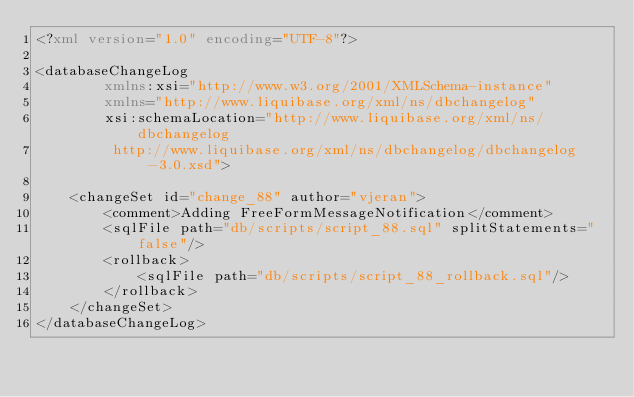Convert code to text. <code><loc_0><loc_0><loc_500><loc_500><_XML_><?xml version="1.0" encoding="UTF-8"?>

<databaseChangeLog
        xmlns:xsi="http://www.w3.org/2001/XMLSchema-instance"
        xmlns="http://www.liquibase.org/xml/ns/dbchangelog"
        xsi:schemaLocation="http://www.liquibase.org/xml/ns/dbchangelog
         http://www.liquibase.org/xml/ns/dbchangelog/dbchangelog-3.0.xsd">

    <changeSet id="change_88" author="vjeran">
        <comment>Adding FreeFormMessageNotification</comment>
        <sqlFile path="db/scripts/script_88.sql" splitStatements="false"/>
        <rollback>
            <sqlFile path="db/scripts/script_88_rollback.sql"/>
        </rollback>
    </changeSet>
</databaseChangeLog>
</code> 